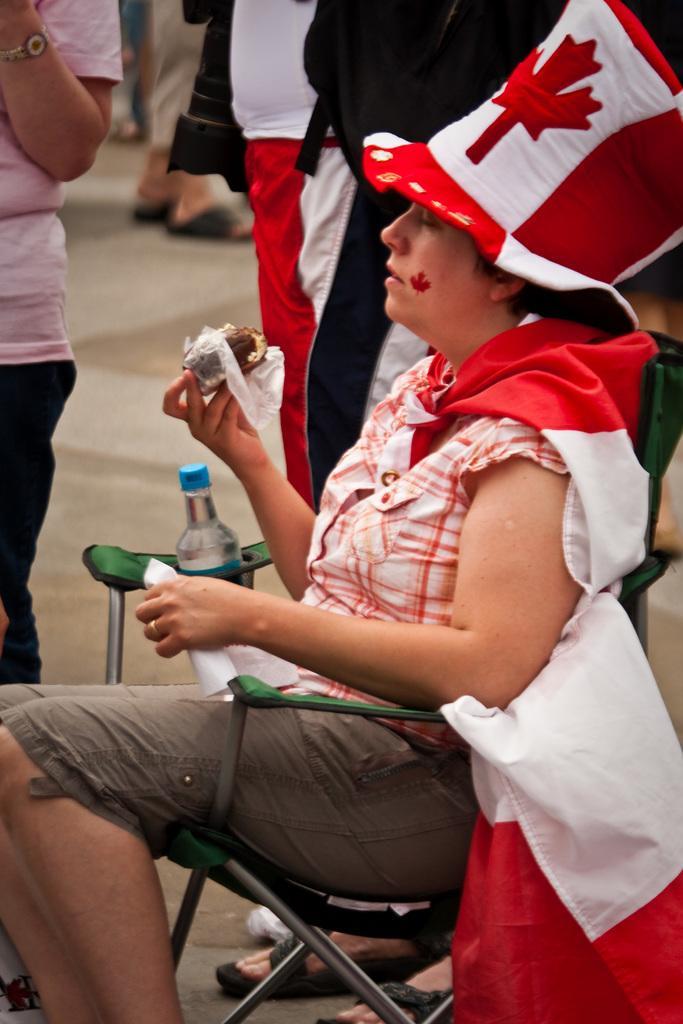Can you describe this image briefly? On the right side, there is a person wearing a cap, holding a food item with one hand, holding a white color paper with the other hand and sitting on a chair. In the background, there are other persons standing. 